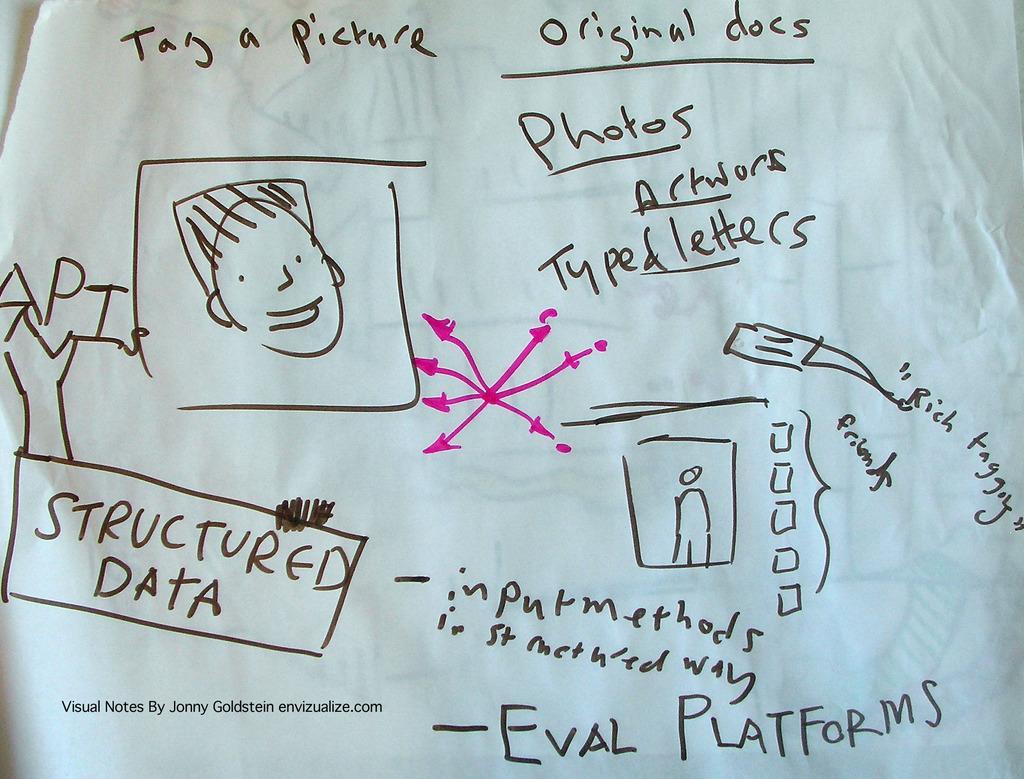Can you describe this image briefly? In this image we can see a paper and there is some text written on it and we can see some pictures which resembles a person. 